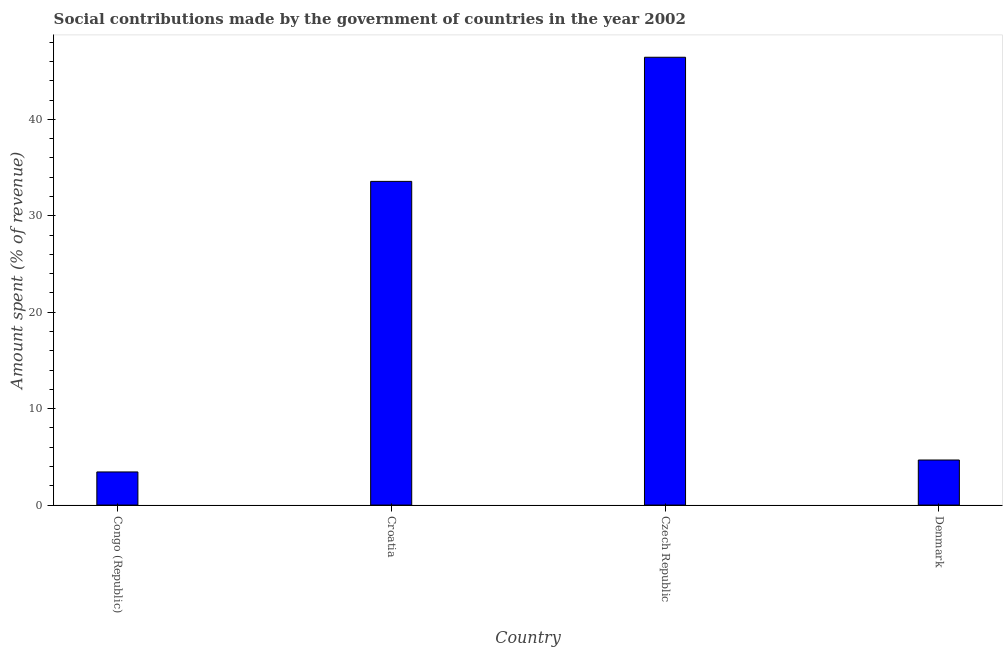What is the title of the graph?
Make the answer very short. Social contributions made by the government of countries in the year 2002. What is the label or title of the Y-axis?
Give a very brief answer. Amount spent (% of revenue). What is the amount spent in making social contributions in Croatia?
Keep it short and to the point. 33.57. Across all countries, what is the maximum amount spent in making social contributions?
Offer a very short reply. 46.44. Across all countries, what is the minimum amount spent in making social contributions?
Give a very brief answer. 3.44. In which country was the amount spent in making social contributions maximum?
Offer a very short reply. Czech Republic. In which country was the amount spent in making social contributions minimum?
Offer a terse response. Congo (Republic). What is the sum of the amount spent in making social contributions?
Your answer should be compact. 88.13. What is the difference between the amount spent in making social contributions in Congo (Republic) and Denmark?
Your answer should be compact. -1.24. What is the average amount spent in making social contributions per country?
Your answer should be compact. 22.03. What is the median amount spent in making social contributions?
Keep it short and to the point. 19.12. In how many countries, is the amount spent in making social contributions greater than 42 %?
Ensure brevity in your answer.  1. What is the ratio of the amount spent in making social contributions in Czech Republic to that in Denmark?
Keep it short and to the point. 9.94. Is the difference between the amount spent in making social contributions in Congo (Republic) and Czech Republic greater than the difference between any two countries?
Make the answer very short. Yes. What is the difference between the highest and the second highest amount spent in making social contributions?
Offer a terse response. 12.87. What is the difference between the highest and the lowest amount spent in making social contributions?
Provide a succinct answer. 43.01. How many bars are there?
Offer a very short reply. 4. What is the difference between two consecutive major ticks on the Y-axis?
Your answer should be very brief. 10. Are the values on the major ticks of Y-axis written in scientific E-notation?
Ensure brevity in your answer.  No. What is the Amount spent (% of revenue) in Congo (Republic)?
Provide a short and direct response. 3.44. What is the Amount spent (% of revenue) in Croatia?
Your answer should be compact. 33.57. What is the Amount spent (% of revenue) of Czech Republic?
Give a very brief answer. 46.44. What is the Amount spent (% of revenue) of Denmark?
Provide a short and direct response. 4.67. What is the difference between the Amount spent (% of revenue) in Congo (Republic) and Croatia?
Your answer should be compact. -30.14. What is the difference between the Amount spent (% of revenue) in Congo (Republic) and Czech Republic?
Your answer should be very brief. -43.01. What is the difference between the Amount spent (% of revenue) in Congo (Republic) and Denmark?
Ensure brevity in your answer.  -1.24. What is the difference between the Amount spent (% of revenue) in Croatia and Czech Republic?
Provide a succinct answer. -12.87. What is the difference between the Amount spent (% of revenue) in Croatia and Denmark?
Offer a very short reply. 28.9. What is the difference between the Amount spent (% of revenue) in Czech Republic and Denmark?
Offer a terse response. 41.77. What is the ratio of the Amount spent (% of revenue) in Congo (Republic) to that in Croatia?
Keep it short and to the point. 0.1. What is the ratio of the Amount spent (% of revenue) in Congo (Republic) to that in Czech Republic?
Provide a short and direct response. 0.07. What is the ratio of the Amount spent (% of revenue) in Congo (Republic) to that in Denmark?
Make the answer very short. 0.73. What is the ratio of the Amount spent (% of revenue) in Croatia to that in Czech Republic?
Give a very brief answer. 0.72. What is the ratio of the Amount spent (% of revenue) in Croatia to that in Denmark?
Make the answer very short. 7.18. What is the ratio of the Amount spent (% of revenue) in Czech Republic to that in Denmark?
Offer a terse response. 9.94. 